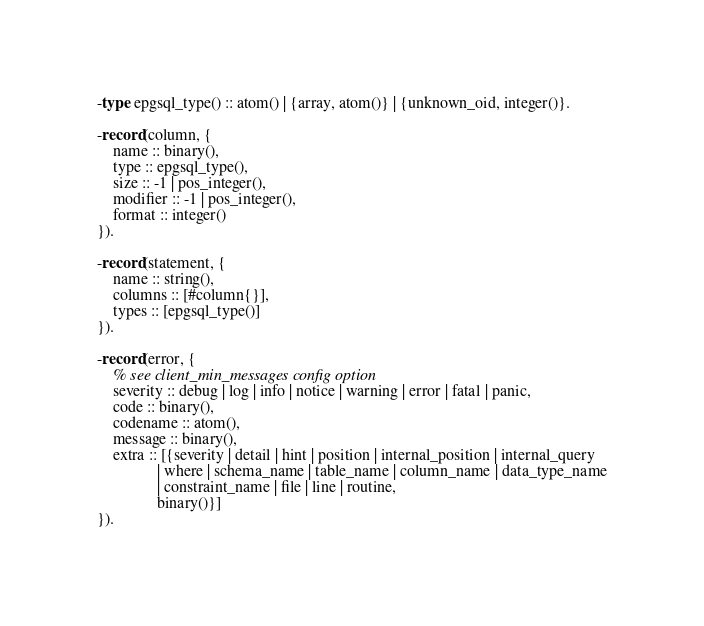<code> <loc_0><loc_0><loc_500><loc_500><_Erlang_>-type epgsql_type() :: atom() | {array, atom()} | {unknown_oid, integer()}.

-record(column, {
    name :: binary(),
    type :: epgsql_type(),
    size :: -1 | pos_integer(),
    modifier :: -1 | pos_integer(),
    format :: integer()
}).

-record(statement, {
    name :: string(),
    columns :: [#column{}],
    types :: [epgsql_type()]
}).

-record(error, {
    % see client_min_messages config option
    severity :: debug | log | info | notice | warning | error | fatal | panic,
    code :: binary(),
    codename :: atom(),
    message :: binary(),
    extra :: [{severity | detail | hint | position | internal_position | internal_query
               | where | schema_name | table_name | column_name | data_type_name
               | constraint_name | file | line | routine,
               binary()}]
}).
</code> 